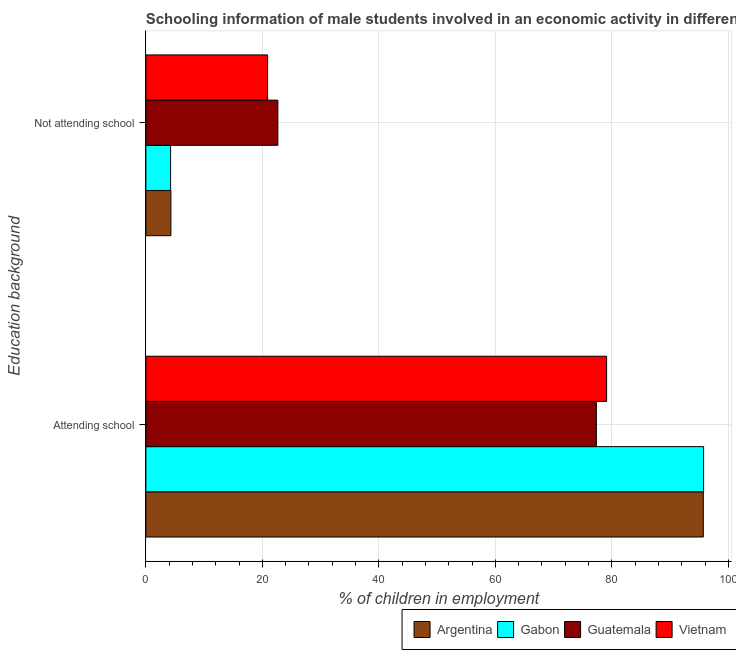Are the number of bars per tick equal to the number of legend labels?
Provide a short and direct response. Yes. What is the label of the 1st group of bars from the top?
Make the answer very short. Not attending school. What is the percentage of employed males who are not attending school in Vietnam?
Provide a succinct answer. 20.9. Across all countries, what is the maximum percentage of employed males who are attending school?
Keep it short and to the point. 95.75. Across all countries, what is the minimum percentage of employed males who are attending school?
Your answer should be compact. 77.34. In which country was the percentage of employed males who are not attending school maximum?
Make the answer very short. Guatemala. In which country was the percentage of employed males who are attending school minimum?
Your response must be concise. Guatemala. What is the total percentage of employed males who are attending school in the graph?
Provide a short and direct response. 347.89. What is the difference between the percentage of employed males who are not attending school in Argentina and that in Guatemala?
Ensure brevity in your answer.  -18.36. What is the difference between the percentage of employed males who are not attending school in Argentina and the percentage of employed males who are attending school in Guatemala?
Offer a very short reply. -73.04. What is the average percentage of employed males who are not attending school per country?
Give a very brief answer. 13.03. What is the difference between the percentage of employed males who are attending school and percentage of employed males who are not attending school in Vietnam?
Your answer should be very brief. 58.2. What is the ratio of the percentage of employed males who are attending school in Argentina to that in Vietnam?
Your response must be concise. 1.21. Is the percentage of employed males who are attending school in Gabon less than that in Argentina?
Keep it short and to the point. No. In how many countries, is the percentage of employed males who are not attending school greater than the average percentage of employed males who are not attending school taken over all countries?
Offer a very short reply. 2. What does the 2nd bar from the top in Not attending school represents?
Ensure brevity in your answer.  Guatemala. What does the 1st bar from the bottom in Attending school represents?
Provide a short and direct response. Argentina. What is the difference between two consecutive major ticks on the X-axis?
Your answer should be compact. 20. Are the values on the major ticks of X-axis written in scientific E-notation?
Provide a short and direct response. No. Does the graph contain any zero values?
Offer a terse response. No. Does the graph contain grids?
Your answer should be compact. Yes. Where does the legend appear in the graph?
Give a very brief answer. Bottom right. How are the legend labels stacked?
Your answer should be very brief. Horizontal. What is the title of the graph?
Make the answer very short. Schooling information of male students involved in an economic activity in different countries. Does "Lithuania" appear as one of the legend labels in the graph?
Your answer should be very brief. No. What is the label or title of the X-axis?
Offer a terse response. % of children in employment. What is the label or title of the Y-axis?
Offer a terse response. Education background. What is the % of children in employment of Argentina in Attending school?
Ensure brevity in your answer.  95.7. What is the % of children in employment in Gabon in Attending school?
Offer a very short reply. 95.75. What is the % of children in employment of Guatemala in Attending school?
Keep it short and to the point. 77.34. What is the % of children in employment of Vietnam in Attending school?
Ensure brevity in your answer.  79.1. What is the % of children in employment in Gabon in Not attending school?
Give a very brief answer. 4.25. What is the % of children in employment of Guatemala in Not attending school?
Offer a very short reply. 22.66. What is the % of children in employment of Vietnam in Not attending school?
Provide a succinct answer. 20.9. Across all Education background, what is the maximum % of children in employment in Argentina?
Your answer should be very brief. 95.7. Across all Education background, what is the maximum % of children in employment of Gabon?
Offer a very short reply. 95.75. Across all Education background, what is the maximum % of children in employment in Guatemala?
Offer a terse response. 77.34. Across all Education background, what is the maximum % of children in employment of Vietnam?
Your response must be concise. 79.1. Across all Education background, what is the minimum % of children in employment of Gabon?
Provide a short and direct response. 4.25. Across all Education background, what is the minimum % of children in employment of Guatemala?
Provide a short and direct response. 22.66. Across all Education background, what is the minimum % of children in employment in Vietnam?
Keep it short and to the point. 20.9. What is the total % of children in employment of Gabon in the graph?
Your answer should be very brief. 100. What is the total % of children in employment in Guatemala in the graph?
Provide a short and direct response. 100. What is the total % of children in employment of Vietnam in the graph?
Provide a short and direct response. 100. What is the difference between the % of children in employment in Argentina in Attending school and that in Not attending school?
Make the answer very short. 91.4. What is the difference between the % of children in employment of Gabon in Attending school and that in Not attending school?
Provide a succinct answer. 91.5. What is the difference between the % of children in employment in Guatemala in Attending school and that in Not attending school?
Provide a succinct answer. 54.68. What is the difference between the % of children in employment in Vietnam in Attending school and that in Not attending school?
Offer a very short reply. 58.2. What is the difference between the % of children in employment in Argentina in Attending school and the % of children in employment in Gabon in Not attending school?
Your answer should be compact. 91.45. What is the difference between the % of children in employment of Argentina in Attending school and the % of children in employment of Guatemala in Not attending school?
Keep it short and to the point. 73.04. What is the difference between the % of children in employment in Argentina in Attending school and the % of children in employment in Vietnam in Not attending school?
Give a very brief answer. 74.8. What is the difference between the % of children in employment in Gabon in Attending school and the % of children in employment in Guatemala in Not attending school?
Offer a very short reply. 73.09. What is the difference between the % of children in employment of Gabon in Attending school and the % of children in employment of Vietnam in Not attending school?
Offer a terse response. 74.85. What is the difference between the % of children in employment in Guatemala in Attending school and the % of children in employment in Vietnam in Not attending school?
Provide a short and direct response. 56.44. What is the average % of children in employment of Guatemala per Education background?
Keep it short and to the point. 50. What is the average % of children in employment of Vietnam per Education background?
Your response must be concise. 50. What is the difference between the % of children in employment in Argentina and % of children in employment in Gabon in Attending school?
Provide a succinct answer. -0.05. What is the difference between the % of children in employment in Argentina and % of children in employment in Guatemala in Attending school?
Your response must be concise. 18.36. What is the difference between the % of children in employment of Gabon and % of children in employment of Guatemala in Attending school?
Provide a succinct answer. 18.41. What is the difference between the % of children in employment in Gabon and % of children in employment in Vietnam in Attending school?
Make the answer very short. 16.65. What is the difference between the % of children in employment of Guatemala and % of children in employment of Vietnam in Attending school?
Ensure brevity in your answer.  -1.76. What is the difference between the % of children in employment in Argentina and % of children in employment in Gabon in Not attending school?
Provide a short and direct response. 0.05. What is the difference between the % of children in employment in Argentina and % of children in employment in Guatemala in Not attending school?
Make the answer very short. -18.36. What is the difference between the % of children in employment of Argentina and % of children in employment of Vietnam in Not attending school?
Offer a very short reply. -16.6. What is the difference between the % of children in employment of Gabon and % of children in employment of Guatemala in Not attending school?
Give a very brief answer. -18.41. What is the difference between the % of children in employment in Gabon and % of children in employment in Vietnam in Not attending school?
Keep it short and to the point. -16.65. What is the difference between the % of children in employment in Guatemala and % of children in employment in Vietnam in Not attending school?
Your answer should be compact. 1.76. What is the ratio of the % of children in employment of Argentina in Attending school to that in Not attending school?
Your response must be concise. 22.26. What is the ratio of the % of children in employment in Gabon in Attending school to that in Not attending school?
Your answer should be very brief. 22.53. What is the ratio of the % of children in employment of Guatemala in Attending school to that in Not attending school?
Your answer should be very brief. 3.41. What is the ratio of the % of children in employment of Vietnam in Attending school to that in Not attending school?
Keep it short and to the point. 3.78. What is the difference between the highest and the second highest % of children in employment in Argentina?
Your response must be concise. 91.4. What is the difference between the highest and the second highest % of children in employment of Gabon?
Provide a short and direct response. 91.5. What is the difference between the highest and the second highest % of children in employment of Guatemala?
Your answer should be very brief. 54.68. What is the difference between the highest and the second highest % of children in employment of Vietnam?
Your response must be concise. 58.2. What is the difference between the highest and the lowest % of children in employment of Argentina?
Give a very brief answer. 91.4. What is the difference between the highest and the lowest % of children in employment in Gabon?
Ensure brevity in your answer.  91.5. What is the difference between the highest and the lowest % of children in employment in Guatemala?
Make the answer very short. 54.68. What is the difference between the highest and the lowest % of children in employment of Vietnam?
Keep it short and to the point. 58.2. 